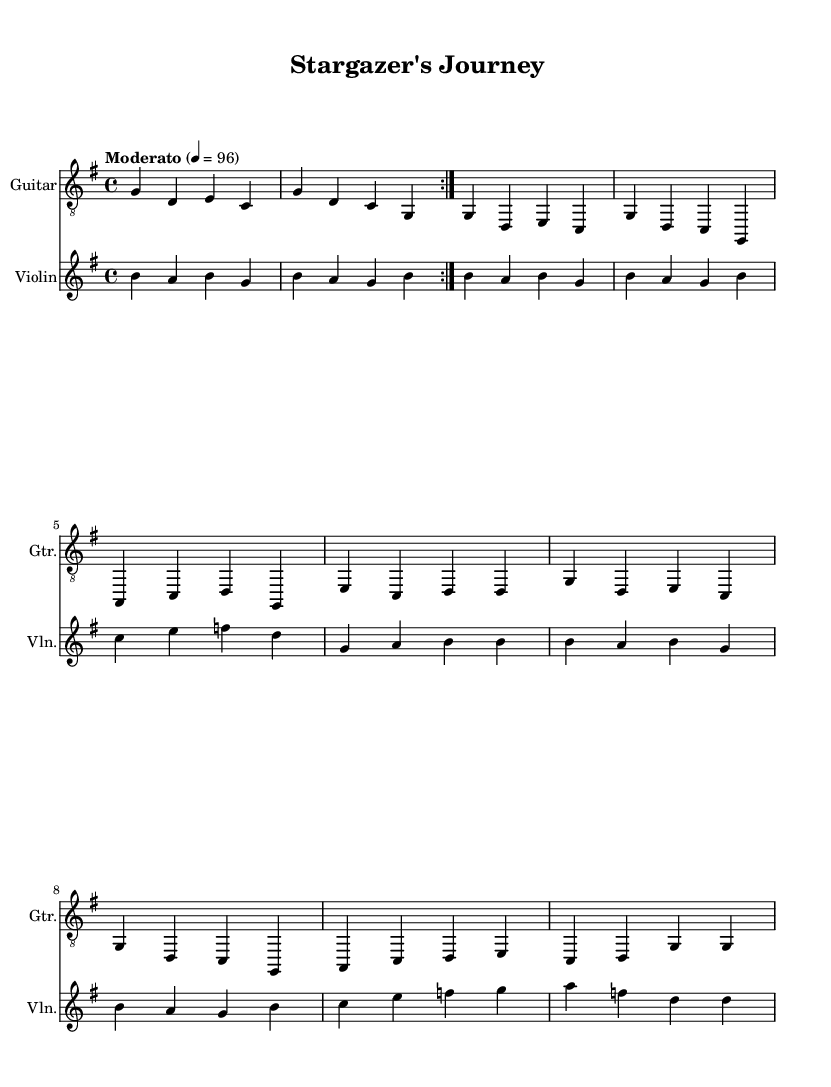What is the key signature of this music? The key signature is indicated at the beginning of the staff and shows one sharp, which indicates that the piece is in G major.
Answer: G major What is the time signature of this music? The time signature can be found at the beginning of the piece and is shown as 4/4, meaning there are four beats in each measure.
Answer: 4/4 What is the tempo marking of this piece? The tempo marking "Moderato" can be seen above the staff, along with a metronome marking of 96 beats per minute, which indicates a moderate speed for playing.
Answer: Moderato 96 How many measures are in the repeated section of music? By counting the measures in the repeated volta section of both instruments, we see that there are 4 measures included before the repeat begins again.
Answer: 4 What instrument plays the melody along with the guitar? Looking at the score, we notice that the violin is the instrument that accompanies the guitar, as it's depicted in the second staff.
Answer: Violin How does the violin part differ in its note range compared to the guitar? Upon examining both staves, the violin part is written an octave higher than the guitar part, which means it plays in a higher pitch range.
Answer: Higher pitch What is the theme of this contemporary folk music? The title "Stargazer's Journey" suggests a theme related to space exploration and astronomy, which is reflective in the stylistic choices made in the music.
Answer: Space exploration 